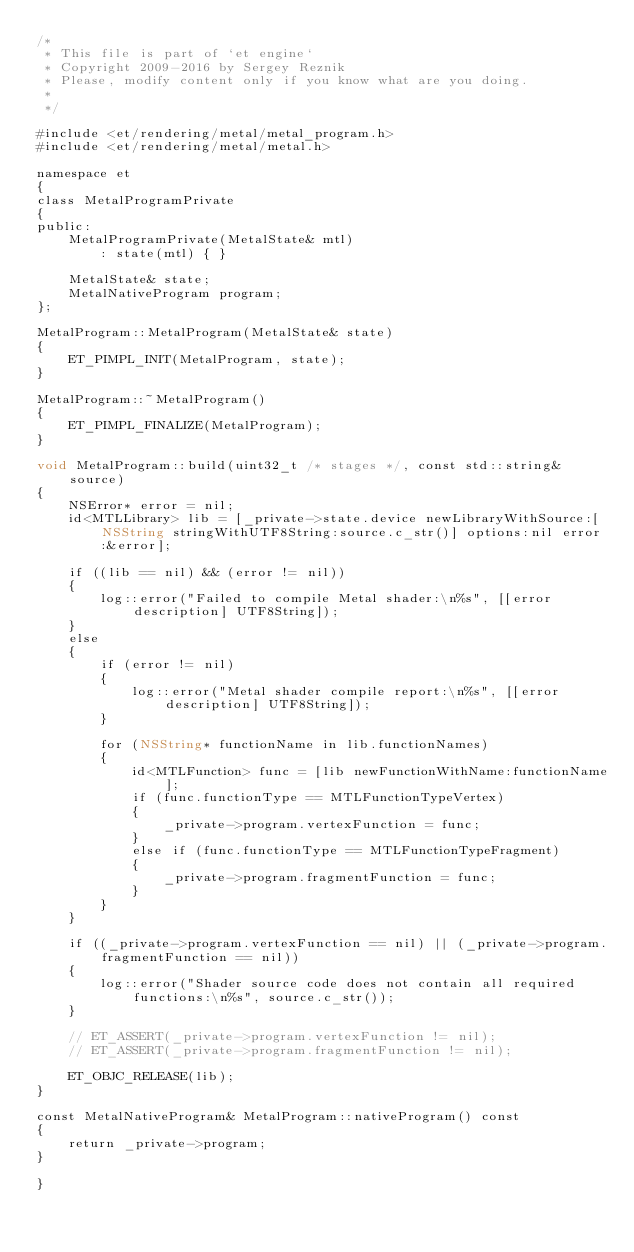Convert code to text. <code><loc_0><loc_0><loc_500><loc_500><_ObjectiveC_>/*
 * This file is part of `et engine`
 * Copyright 2009-2016 by Sergey Reznik
 * Please, modify content only if you know what are you doing.
 *
 */

#include <et/rendering/metal/metal_program.h>
#include <et/rendering/metal/metal.h>

namespace et
{
class MetalProgramPrivate
{
public:
	MetalProgramPrivate(MetalState& mtl)
		: state(mtl) { }

	MetalState& state;
    MetalNativeProgram program;
};

MetalProgram::MetalProgram(MetalState& state)
{
    ET_PIMPL_INIT(MetalProgram, state);
}

MetalProgram::~MetalProgram()
{
	ET_PIMPL_FINALIZE(MetalProgram);
}
    
void MetalProgram::build(uint32_t /* stages */, const std::string& source)
{
	NSError* error = nil;
	id<MTLLibrary> lib = [_private->state.device newLibraryWithSource:[NSString stringWithUTF8String:source.c_str()] options:nil error:&error];

	if ((lib == nil) && (error != nil))
	{
		log::error("Failed to compile Metal shader:\n%s", [[error description] UTF8String]);
	}
	else
	{
		if (error != nil)
		{
			log::error("Metal shader compile report:\n%s", [[error description] UTF8String]);
		}

		for (NSString* functionName in lib.functionNames)
		{
			id<MTLFunction> func = [lib newFunctionWithName:functionName];
			if (func.functionType == MTLFunctionTypeVertex)
			{
				_private->program.vertexFunction = func;
			}
			else if (func.functionType == MTLFunctionTypeFragment)
			{
				_private->program.fragmentFunction = func;
			}
		}
	}

	if ((_private->program.vertexFunction == nil) || (_private->program.fragmentFunction == nil))
	{
		log::error("Shader source code does not contain all required functions:\n%s", source.c_str());
	}

	// ET_ASSERT(_private->program.vertexFunction != nil);
	// ET_ASSERT(_private->program.fragmentFunction != nil);

	ET_OBJC_RELEASE(lib);
}
    
const MetalNativeProgram& MetalProgram::nativeProgram() const
{
    return _private->program;
}

}
</code> 